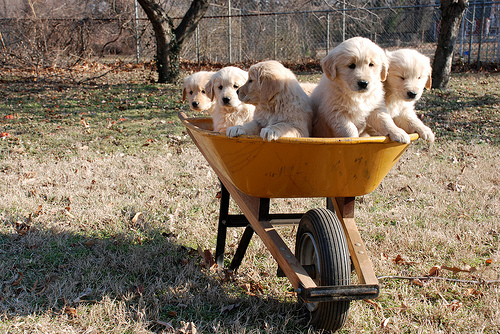<image>
Can you confirm if the dog is behind the tree? No. The dog is not behind the tree. From this viewpoint, the dog appears to be positioned elsewhere in the scene. Is there a puppy above the wheelbarrow? Yes. The puppy is positioned above the wheelbarrow in the vertical space, higher up in the scene. 